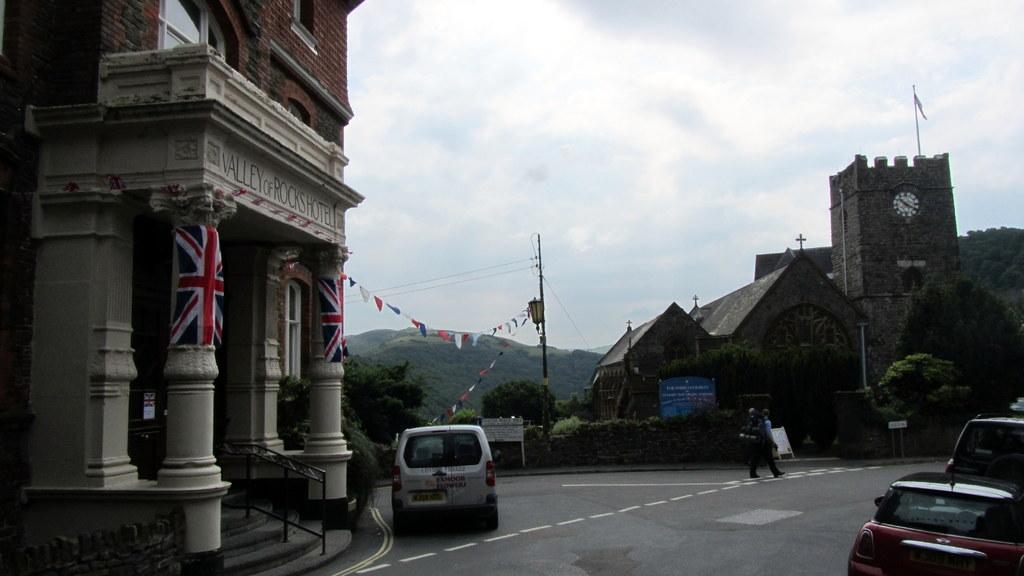What time is the clock at?
Your response must be concise. 10:20. What is the name of the hotel?
Keep it short and to the point. Valley of rocks. 